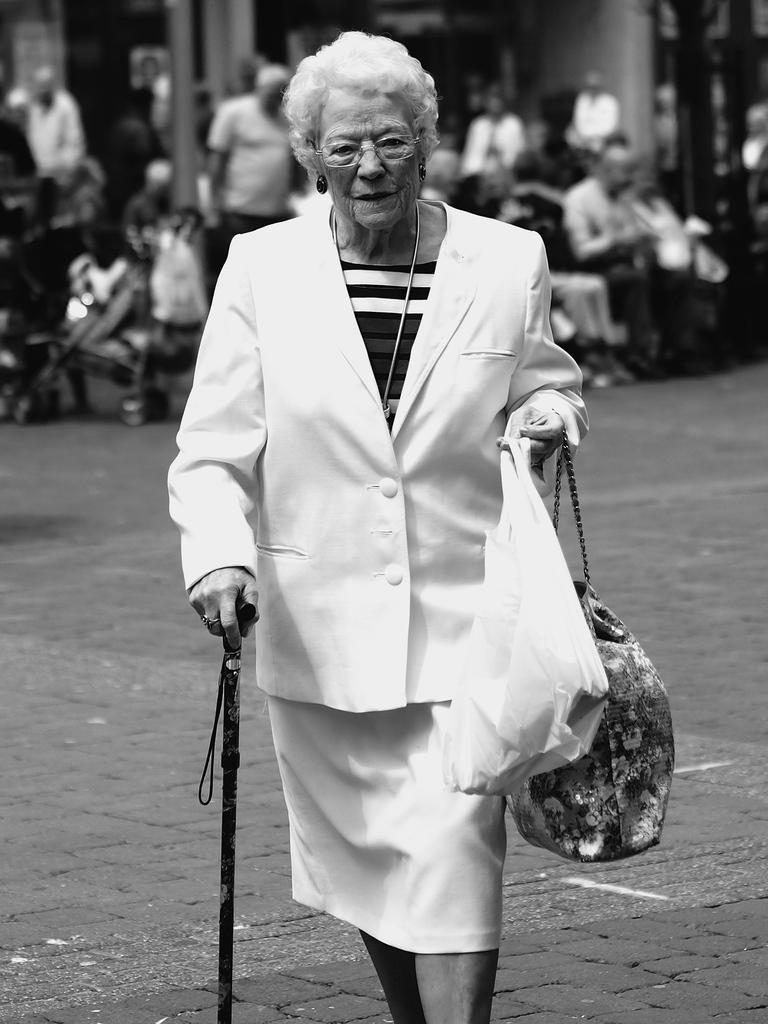What is the color scheme of the image? The image is black and white. Who is the main subject in the image? A woman is highlighted in the image. What can be observed about the woman in the background? There are many persons in the background, and the woman in the background is wearing a white suit and holding a plastic bag and a stick. Can you tell me how many goats are present in the image? There are no goats present in the image. What example of swimming can be seen in the image? There is no swimming or any reference to swimming in the image. 